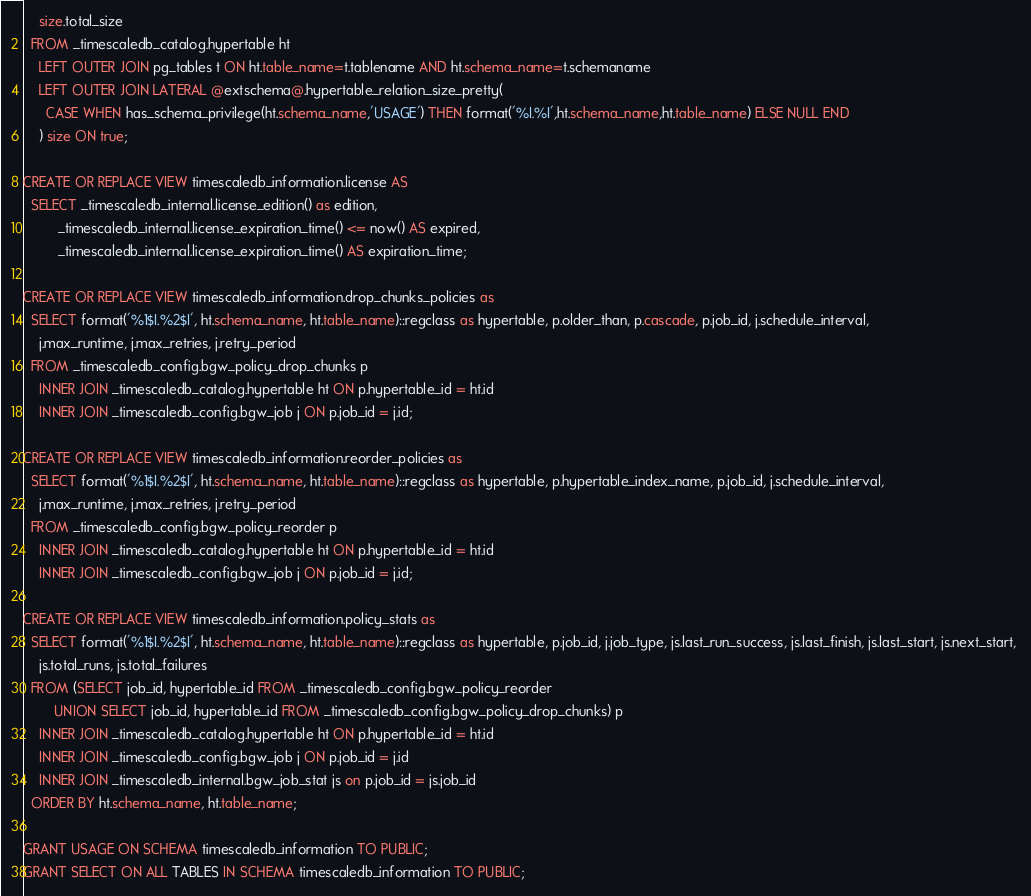Convert code to text. <code><loc_0><loc_0><loc_500><loc_500><_SQL_>    size.total_size
  FROM _timescaledb_catalog.hypertable ht
    LEFT OUTER JOIN pg_tables t ON ht.table_name=t.tablename AND ht.schema_name=t.schemaname
    LEFT OUTER JOIN LATERAL @extschema@.hypertable_relation_size_pretty(
      CASE WHEN has_schema_privilege(ht.schema_name,'USAGE') THEN format('%I.%I',ht.schema_name,ht.table_name) ELSE NULL END
    ) size ON true;

CREATE OR REPLACE VIEW timescaledb_information.license AS
  SELECT _timescaledb_internal.license_edition() as edition,
         _timescaledb_internal.license_expiration_time() <= now() AS expired,
         _timescaledb_internal.license_expiration_time() AS expiration_time;

CREATE OR REPLACE VIEW timescaledb_information.drop_chunks_policies as 
  SELECT format('%1$I.%2$I', ht.schema_name, ht.table_name)::regclass as hypertable, p.older_than, p.cascade, p.job_id, j.schedule_interval,  
    j.max_runtime, j.max_retries, j.retry_period
  FROM _timescaledb_config.bgw_policy_drop_chunks p
    INNER JOIN _timescaledb_catalog.hypertable ht ON p.hypertable_id = ht.id
    INNER JOIN _timescaledb_config.bgw_job j ON p.job_id = j.id;

CREATE OR REPLACE VIEW timescaledb_information.reorder_policies as 
  SELECT format('%1$I.%2$I', ht.schema_name, ht.table_name)::regclass as hypertable, p.hypertable_index_name, p.job_id, j.schedule_interval,  
    j.max_runtime, j.max_retries, j.retry_period
  FROM _timescaledb_config.bgw_policy_reorder p
    INNER JOIN _timescaledb_catalog.hypertable ht ON p.hypertable_id = ht.id
    INNER JOIN _timescaledb_config.bgw_job j ON p.job_id = j.id;

CREATE OR REPLACE VIEW timescaledb_information.policy_stats as 
  SELECT format('%1$I.%2$I', ht.schema_name, ht.table_name)::regclass as hypertable, p.job_id, j.job_type, js.last_run_success, js.last_finish, js.last_start, js.next_start, 
    js.total_runs, js.total_failures 
  FROM (SELECT job_id, hypertable_id FROM _timescaledb_config.bgw_policy_reorder 
        UNION SELECT job_id, hypertable_id FROM _timescaledb_config.bgw_policy_drop_chunks) p  
    INNER JOIN _timescaledb_catalog.hypertable ht ON p.hypertable_id = ht.id
    INNER JOIN _timescaledb_config.bgw_job j ON p.job_id = j.id
    INNER JOIN _timescaledb_internal.bgw_job_stat js on p.job_id = js.job_id
  ORDER BY ht.schema_name, ht.table_name;

GRANT USAGE ON SCHEMA timescaledb_information TO PUBLIC;
GRANT SELECT ON ALL TABLES IN SCHEMA timescaledb_information TO PUBLIC;
</code> 